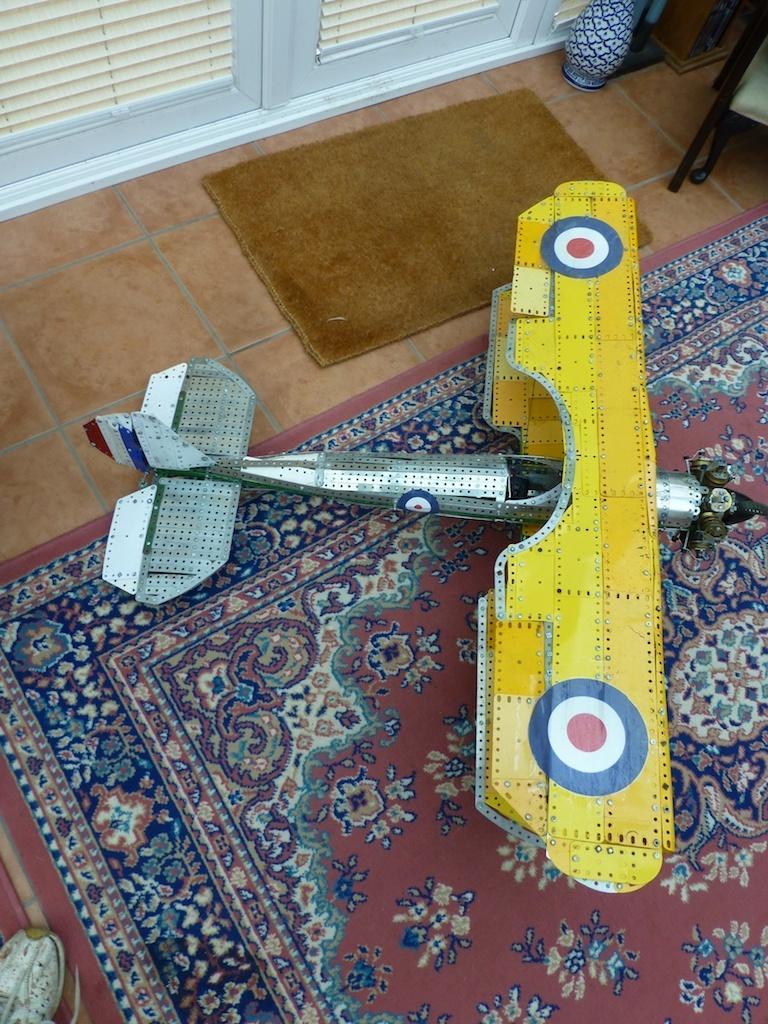Please provide a concise description of this image. In this picture I can see there is a toy aircraft, there is a carpet on the floor, there is a door mat, a door on the left side, few other objects at the right side and there is a shoe at the left side bottom corner of the image. 